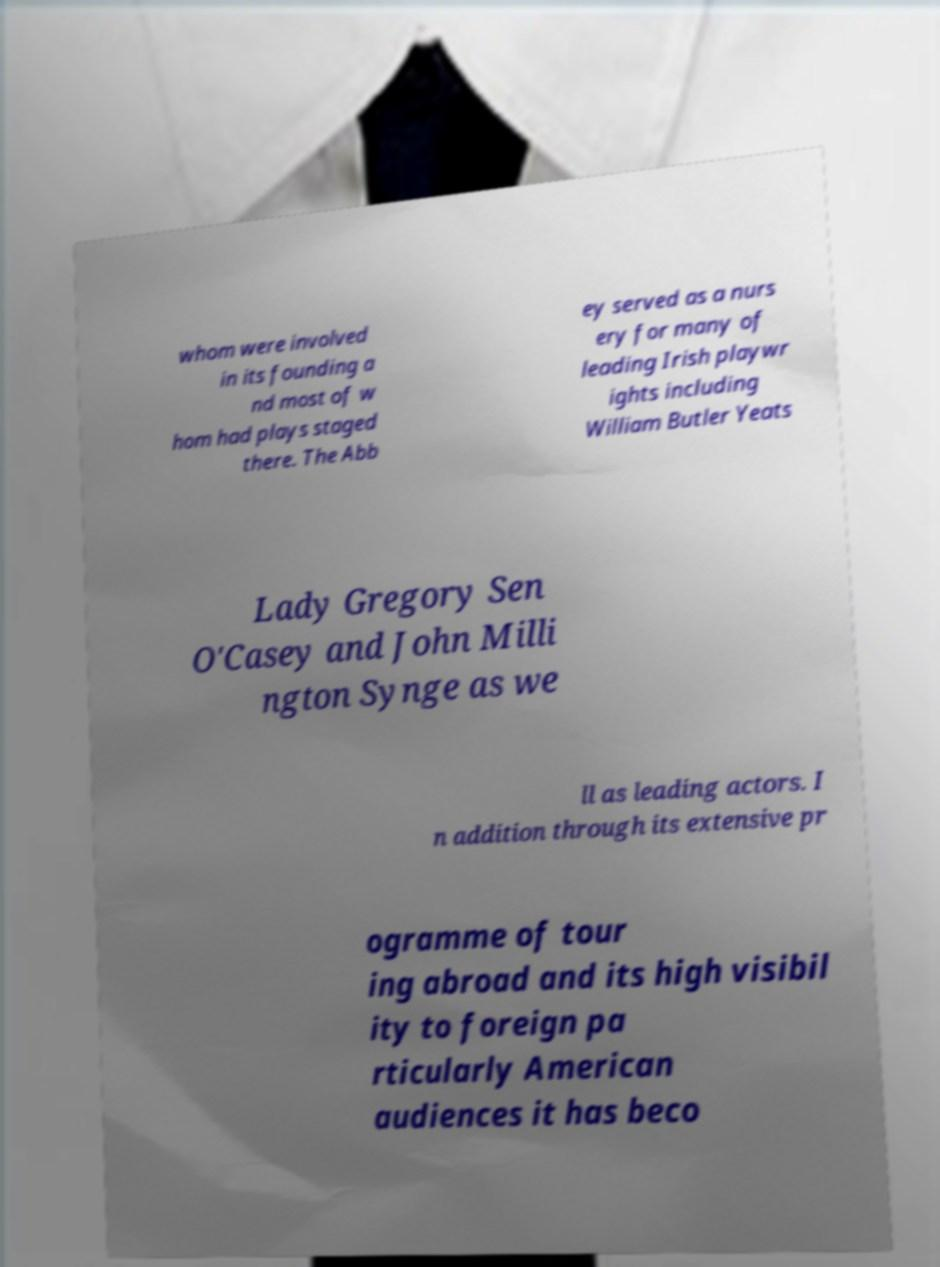I need the written content from this picture converted into text. Can you do that? whom were involved in its founding a nd most of w hom had plays staged there. The Abb ey served as a nurs ery for many of leading Irish playwr ights including William Butler Yeats Lady Gregory Sen O'Casey and John Milli ngton Synge as we ll as leading actors. I n addition through its extensive pr ogramme of tour ing abroad and its high visibil ity to foreign pa rticularly American audiences it has beco 